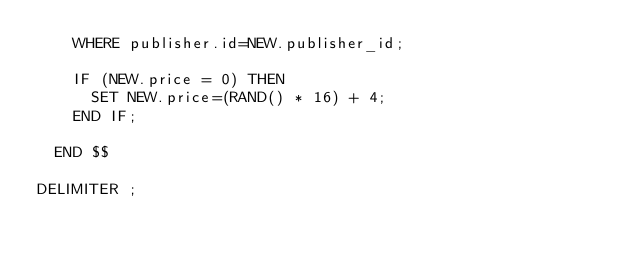<code> <loc_0><loc_0><loc_500><loc_500><_SQL_>		WHERE publisher.id=NEW.publisher_id;
		
		IF (NEW.price = 0) THEN
			SET NEW.price=(RAND() * 16) + 4;
		END IF;
		
	END $$

DELIMITER ;</code> 